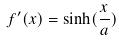Convert formula to latex. <formula><loc_0><loc_0><loc_500><loc_500>f ^ { \prime } ( x ) = \sinh ( \frac { x } { a } )</formula> 